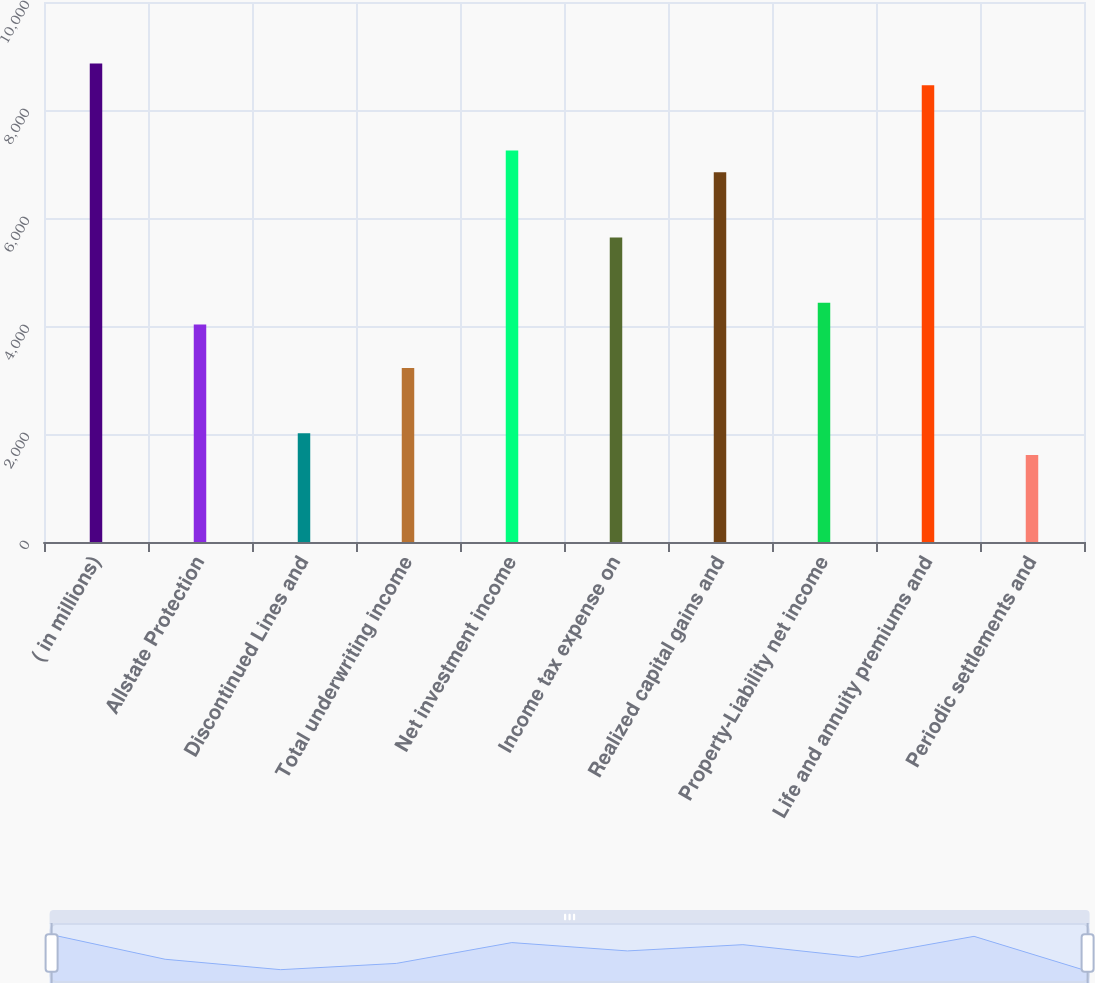Convert chart. <chart><loc_0><loc_0><loc_500><loc_500><bar_chart><fcel>( in millions)<fcel>Allstate Protection<fcel>Discontinued Lines and<fcel>Total underwriting income<fcel>Net investment income<fcel>Income tax expense on<fcel>Realized capital gains and<fcel>Property-Liability net income<fcel>Life and annuity premiums and<fcel>Periodic settlements and<nl><fcel>8862.6<fcel>4029<fcel>2015<fcel>3223.4<fcel>7251.4<fcel>5640.2<fcel>6848.6<fcel>4431.8<fcel>8459.8<fcel>1612.2<nl></chart> 